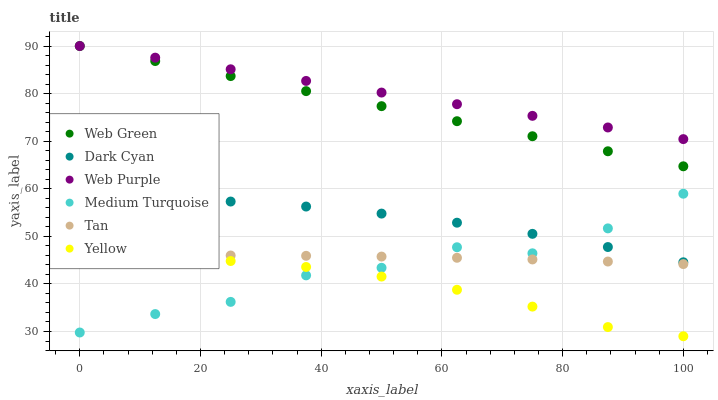Does Yellow have the minimum area under the curve?
Answer yes or no. Yes. Does Web Purple have the maximum area under the curve?
Answer yes or no. Yes. Does Web Green have the minimum area under the curve?
Answer yes or no. No. Does Web Green have the maximum area under the curve?
Answer yes or no. No. Is Web Green the smoothest?
Answer yes or no. Yes. Is Medium Turquoise the roughest?
Answer yes or no. Yes. Is Web Purple the smoothest?
Answer yes or no. No. Is Web Purple the roughest?
Answer yes or no. No. Does Yellow have the lowest value?
Answer yes or no. Yes. Does Web Green have the lowest value?
Answer yes or no. No. Does Web Green have the highest value?
Answer yes or no. Yes. Does Medium Turquoise have the highest value?
Answer yes or no. No. Is Dark Cyan less than Web Green?
Answer yes or no. Yes. Is Web Green greater than Tan?
Answer yes or no. Yes. Does Web Purple intersect Web Green?
Answer yes or no. Yes. Is Web Purple less than Web Green?
Answer yes or no. No. Is Web Purple greater than Web Green?
Answer yes or no. No. Does Dark Cyan intersect Web Green?
Answer yes or no. No. 